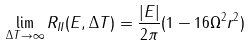<formula> <loc_0><loc_0><loc_500><loc_500>\lim _ { \Delta T \rightarrow \infty } R _ { I I } ( E , \Delta T ) = \frac { | E | } { 2 \pi } ( 1 - 1 6 \Omega ^ { 2 } r ^ { 2 } )</formula> 